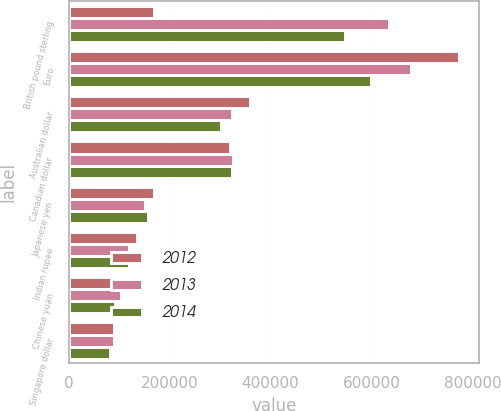Convert chart to OTSL. <chart><loc_0><loc_0><loc_500><loc_500><stacked_bar_chart><ecel><fcel>British pound sterling<fcel>Euro<fcel>Australian dollar<fcel>Canadian dollar<fcel>Japanese yen<fcel>Indian rupee<fcel>Chinese yuan<fcel>Singapore dollar<nl><fcel>2012<fcel>168574<fcel>773753<fcel>359660<fcel>319670<fcel>168574<fcel>135139<fcel>101790<fcel>89343<nl><fcel>2013<fcel>634375<fcel>677258<fcel>322792<fcel>324900<fcel>151050<fcel>118944<fcel>102643<fcel>89509<nl><fcel>2014<fcel>547339<fcel>598621<fcel>302463<fcel>324304<fcel>157007<fcel>119327<fcel>92215<fcel>82069<nl></chart> 